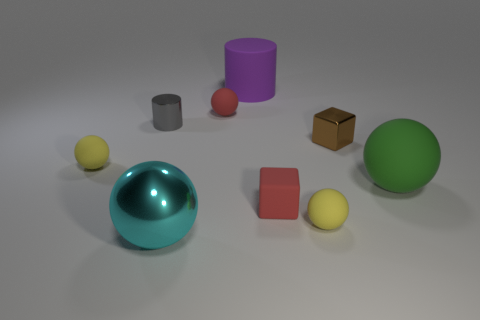What number of big green spheres are the same material as the big purple object?
Your answer should be very brief. 1. There is a tiny block that is made of the same material as the purple object; what color is it?
Provide a short and direct response. Red. What is the size of the rubber ball right of the shiny thing to the right of the small yellow thing that is right of the big cyan metal ball?
Your response must be concise. Large. Are there fewer shiny cylinders than tiny blue matte balls?
Make the answer very short. No. What is the color of the other metal thing that is the same shape as the large green object?
Your answer should be very brief. Cyan. There is a tiny yellow rubber object in front of the small red thing in front of the small brown metallic cube; are there any metallic things that are to the left of it?
Keep it short and to the point. Yes. Is the shape of the big purple thing the same as the tiny brown shiny thing?
Provide a short and direct response. No. Is the number of purple cylinders in front of the small shiny cylinder less than the number of big shiny things?
Make the answer very short. Yes. The small matte ball that is behind the metal thing that is to the right of the ball behind the brown block is what color?
Offer a terse response. Red. How many metallic things are large purple cylinders or big yellow cylinders?
Offer a very short reply. 0. 